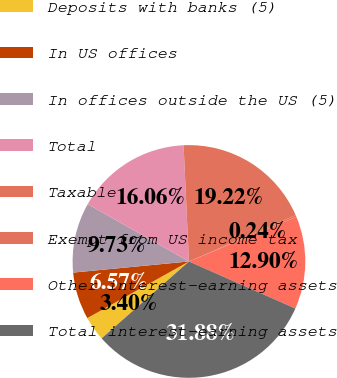<chart> <loc_0><loc_0><loc_500><loc_500><pie_chart><fcel>Deposits with banks (5)<fcel>In US offices<fcel>In offices outside the US (5)<fcel>Total<fcel>Taxable<fcel>Exempt from US income tax<fcel>Other interest-earning assets<fcel>Total interest-earning assets<nl><fcel>3.4%<fcel>6.57%<fcel>9.73%<fcel>16.06%<fcel>19.22%<fcel>0.24%<fcel>12.9%<fcel>31.88%<nl></chart> 